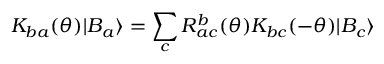Convert formula to latex. <formula><loc_0><loc_0><loc_500><loc_500>K _ { b a } ( \theta ) | B _ { a } \rangle = \sum _ { c } R _ { a c } ^ { b } ( \theta ) K _ { b c } ( - \theta ) | B _ { c } \rangle</formula> 